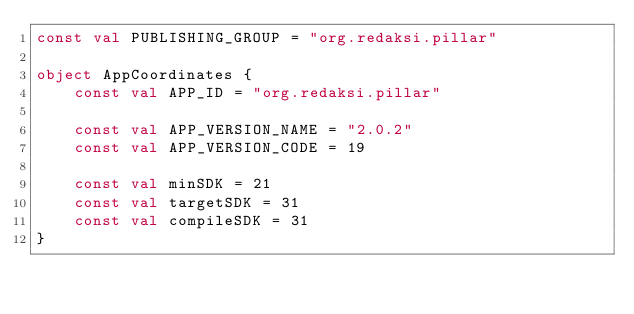Convert code to text. <code><loc_0><loc_0><loc_500><loc_500><_Kotlin_>const val PUBLISHING_GROUP = "org.redaksi.pillar"

object AppCoordinates {
    const val APP_ID = "org.redaksi.pillar"

    const val APP_VERSION_NAME = "2.0.2"
    const val APP_VERSION_CODE = 19

    const val minSDK = 21
    const val targetSDK = 31
    const val compileSDK = 31
}
</code> 